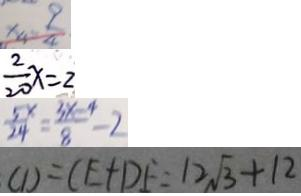<formula> <loc_0><loc_0><loc_500><loc_500>x _ { 4 } = \frac { 9 } { 4 } 
 \frac { 2 } { 2 0 } x = 2 
 \frac { 5 x } { 2 4 } = \frac { 3 x - 4 } { 8 } = - 2 
 C D = C E + D F = 1 2 \sqrt { 3 } + 1 2</formula> 